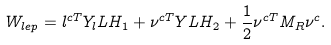Convert formula to latex. <formula><loc_0><loc_0><loc_500><loc_500>W _ { l e p } = l ^ { c T } Y _ { l } L H _ { 1 } + \nu ^ { c T } Y L H _ { 2 } + \frac { 1 } { 2 } \nu ^ { c T } M _ { R } \nu ^ { c } .</formula> 